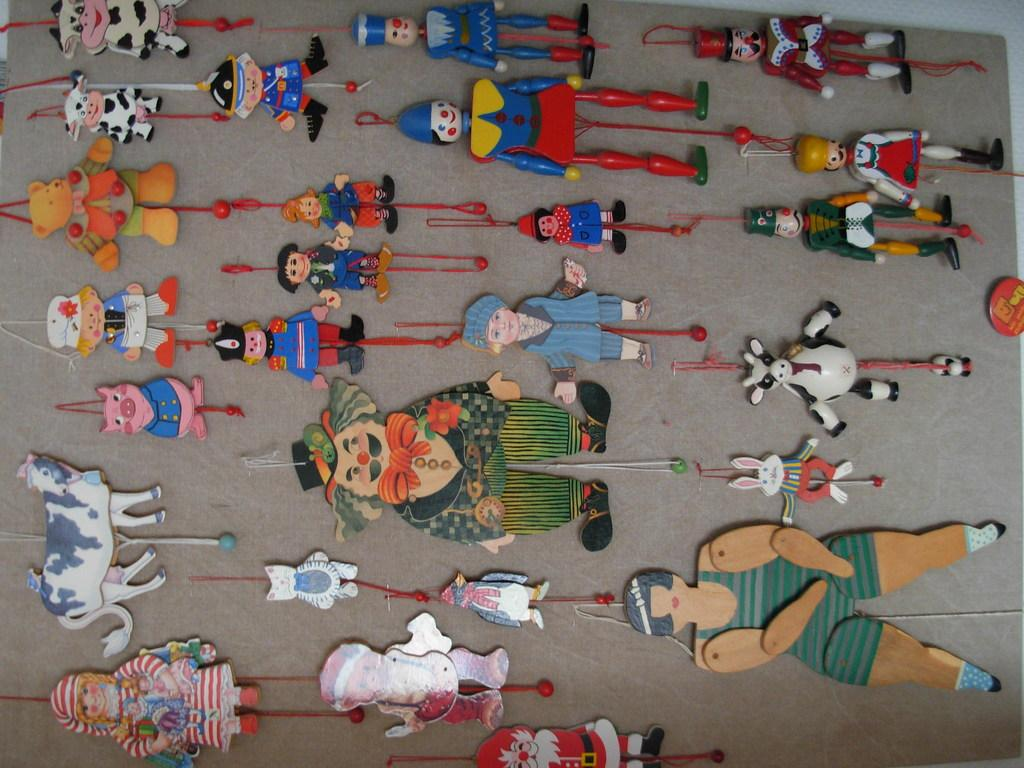What type of toys can be seen in the image? Some of the toys are similar animal toys and some are similar human toys. What is the person in the image doing with the camera? The person is taking a picture. What is the person in the image doing while sitting on the chair? The person is reading a book. What color is the car in the image? The car is red in color. What is the person in the image holding while standing near the car? The person is holding a cup of coffee. What is the person in the image doing with the guitar? The person is playing the guitar. What type of protective gear is the person wearing while riding the bicycle? The person is wearing a helmet. What activity are the group of people in the image engaged in? The people are having a meal. What object is the person in the image holding while standing near the tree? The person is holding a phone. What type of linen is draped over the tree in the image? There is no linen present in the image; it features a person standing near a tree while holding a phone. What type of loss is the person in the image experiencing? There is no indication of any loss in the image; it features a person standing near a tree while holding a phone. What type of face is the person in the image making while holding the guitar? The image does not show the person's face while playing the guitar, only their hands and the guitar itself. 